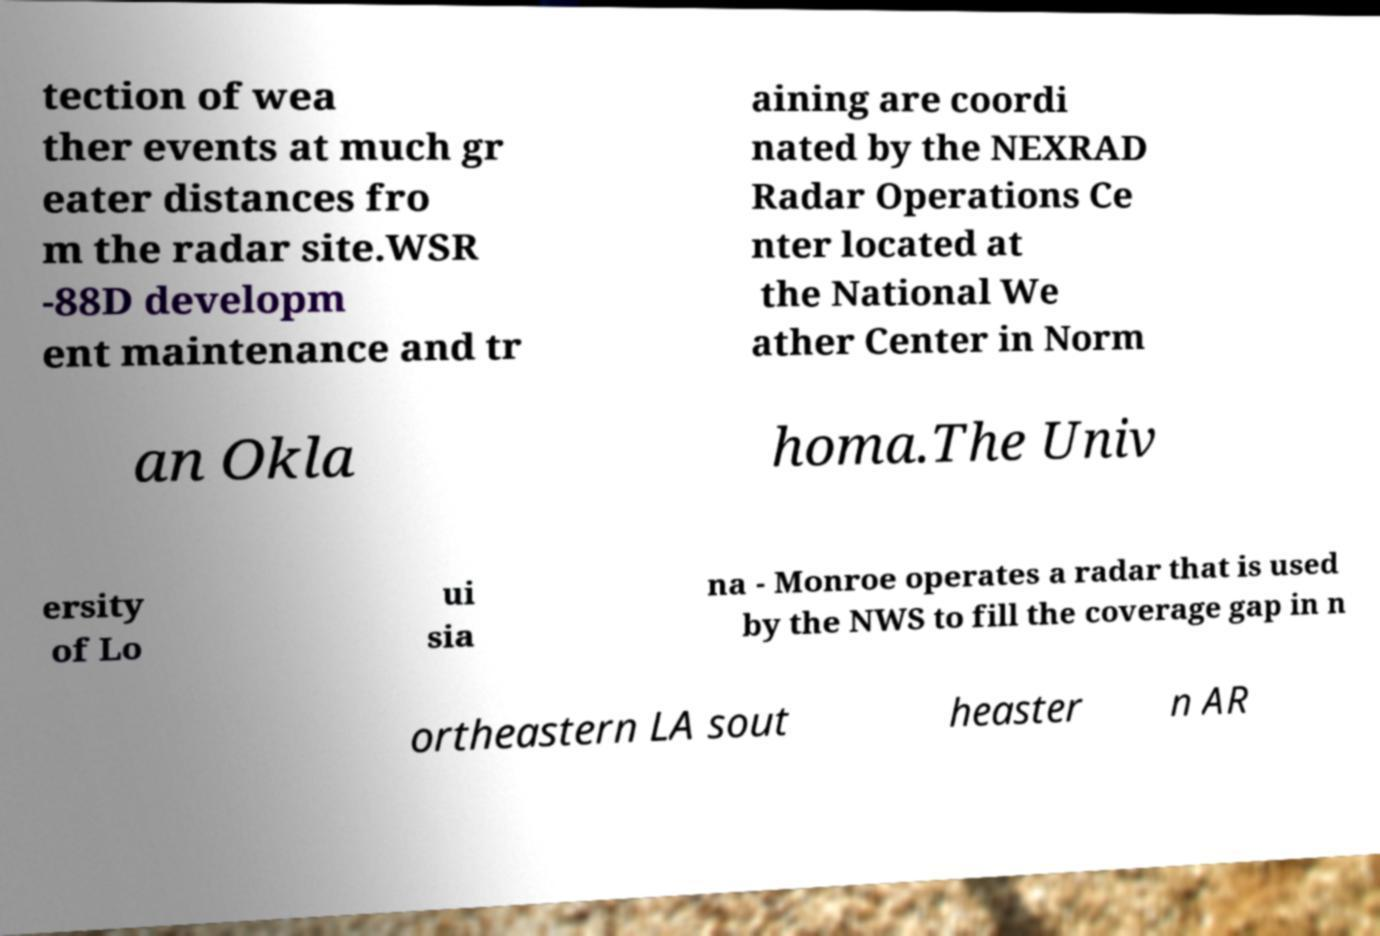What messages or text are displayed in this image? I need them in a readable, typed format. tection of wea ther events at much gr eater distances fro m the radar site.WSR -88D developm ent maintenance and tr aining are coordi nated by the NEXRAD Radar Operations Ce nter located at the National We ather Center in Norm an Okla homa.The Univ ersity of Lo ui sia na - Monroe operates a radar that is used by the NWS to fill the coverage gap in n ortheastern LA sout heaster n AR 